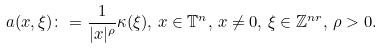Convert formula to latex. <formula><loc_0><loc_0><loc_500><loc_500>a ( x , \xi ) \colon = \frac { 1 } { | x | ^ { \rho } } \kappa ( \xi ) , \, x \in \mathbb { T } ^ { n } , \, x \neq 0 , \, \xi \in \mathbb { Z } ^ { n r } , \, \rho > 0 .</formula> 